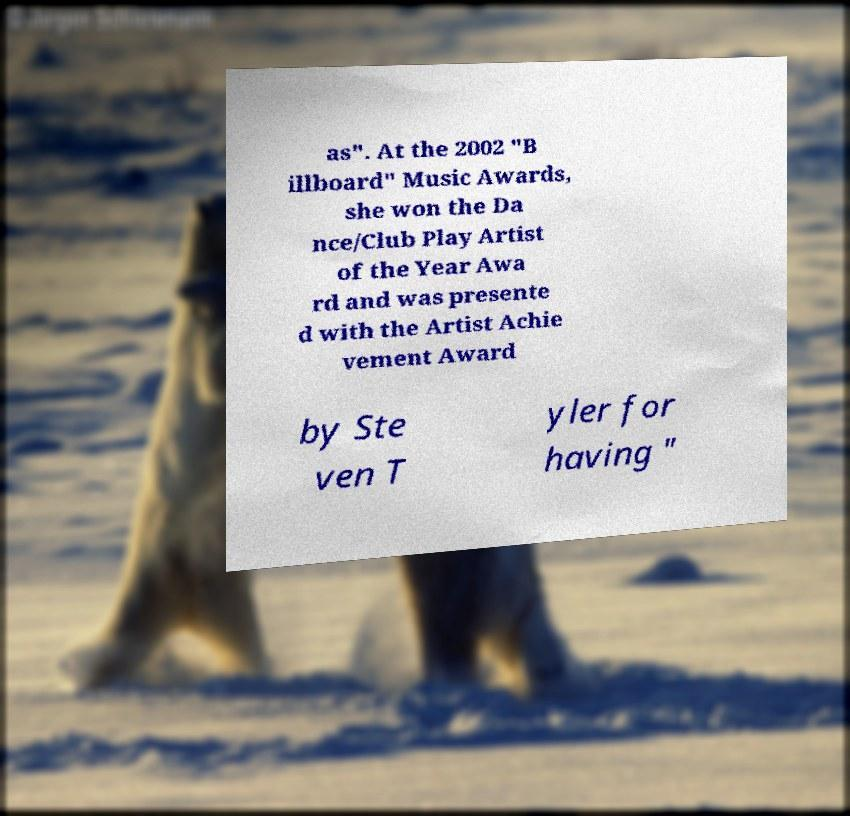There's text embedded in this image that I need extracted. Can you transcribe it verbatim? as". At the 2002 "B illboard" Music Awards, she won the Da nce/Club Play Artist of the Year Awa rd and was presente d with the Artist Achie vement Award by Ste ven T yler for having " 